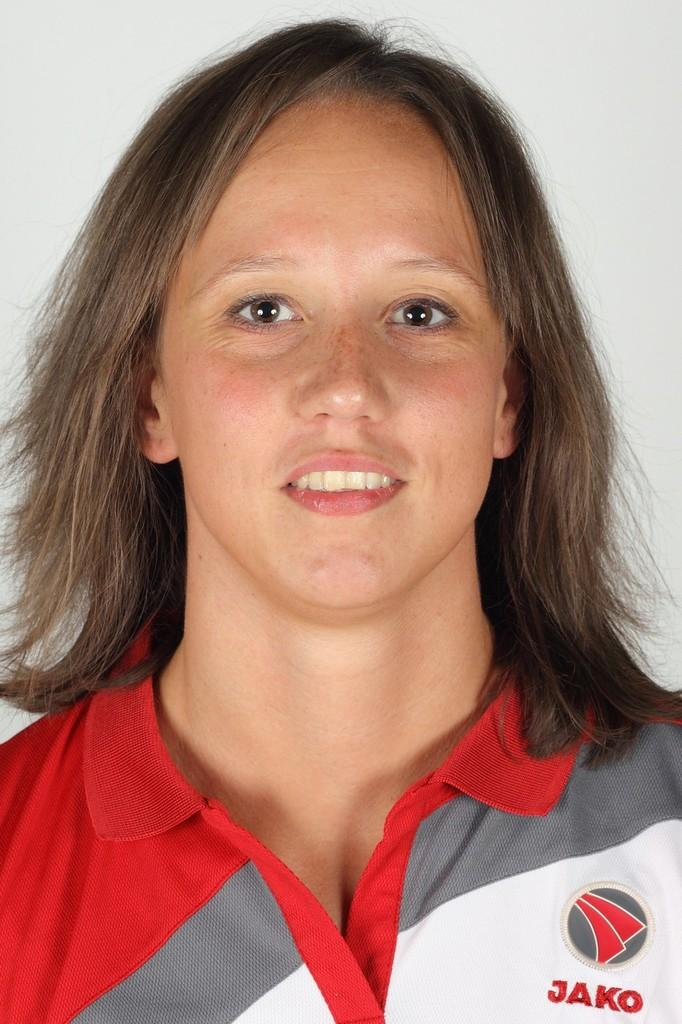Provide a one-sentence caption for the provided image. A woman wearing a red, grey and white shirt that say Jako. 